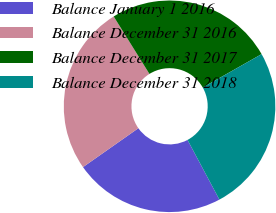Convert chart to OTSL. <chart><loc_0><loc_0><loc_500><loc_500><pie_chart><fcel>Balance January 1 2016<fcel>Balance December 31 2016<fcel>Balance December 31 2017<fcel>Balance December 31 2018<nl><fcel>23.06%<fcel>25.89%<fcel>25.65%<fcel>25.4%<nl></chart> 